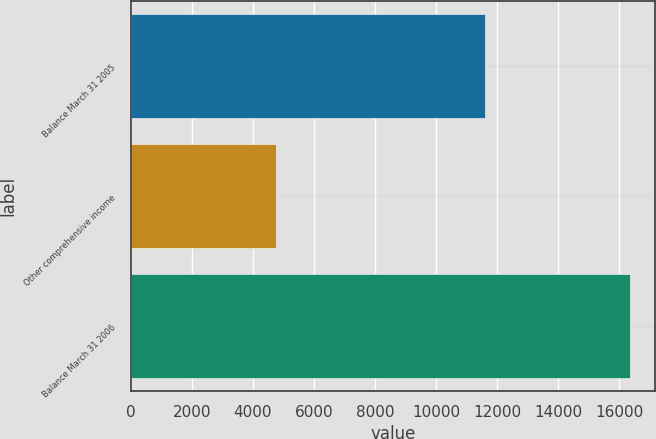<chart> <loc_0><loc_0><loc_500><loc_500><bar_chart><fcel>Balance March 31 2005<fcel>Other comprehensive income<fcel>Balance March 31 2006<nl><fcel>11618<fcel>4751<fcel>16369<nl></chart> 